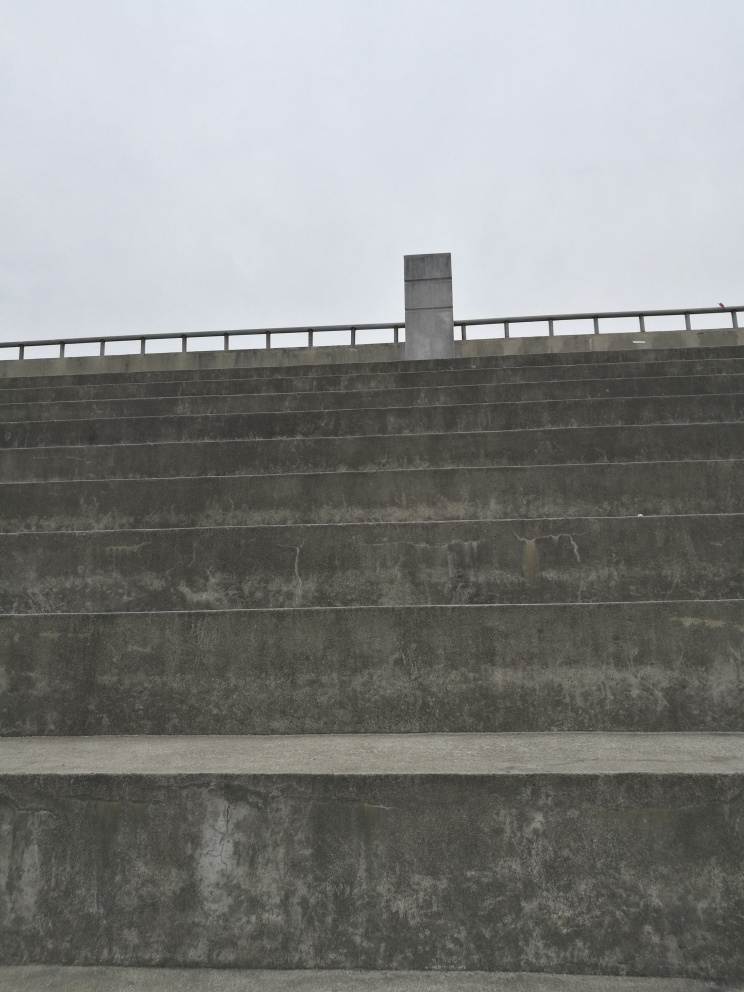What is the weather like in this image? The weather in the image appears to be overcast, with a uniformly grey sky suggesting cloud cover. There are no signs of rain in the image itself, but the overall atmosphere is one of a cloudy, possibly humid day. 